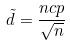Convert formula to latex. <formula><loc_0><loc_0><loc_500><loc_500>\tilde { d } = \frac { n c p } { \sqrt { n } }</formula> 